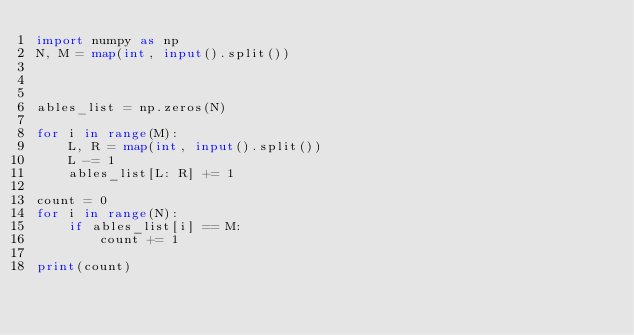<code> <loc_0><loc_0><loc_500><loc_500><_Python_>import numpy as np
N, M = map(int, input().split())



ables_list = np.zeros(N)

for i in range(M):
    L, R = map(int, input().split())
    L -= 1
    ables_list[L: R] += 1

count = 0
for i in range(N):
    if ables_list[i] == M:
        count += 1

print(count)</code> 